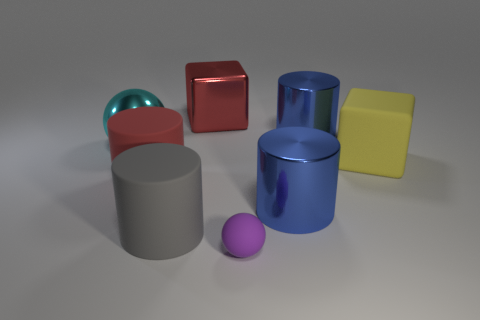Subtract all big red cylinders. How many cylinders are left? 3 Add 2 large cyan metallic things. How many objects exist? 10 Subtract all green blocks. How many blue cylinders are left? 2 Subtract all gray cylinders. How many cylinders are left? 3 Subtract all spheres. How many objects are left? 6 Subtract 1 cylinders. How many cylinders are left? 3 Subtract all blue balls. Subtract all green blocks. How many balls are left? 2 Subtract all blue objects. Subtract all big cyan shiny objects. How many objects are left? 5 Add 1 large blue cylinders. How many large blue cylinders are left? 3 Add 8 blue shiny cylinders. How many blue shiny cylinders exist? 10 